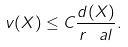<formula> <loc_0><loc_0><loc_500><loc_500>v ( X ) \leq C \frac { d ( X ) } { r ^ { \ } a l } .</formula> 